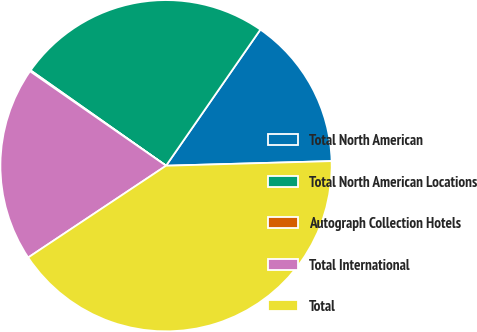Convert chart to OTSL. <chart><loc_0><loc_0><loc_500><loc_500><pie_chart><fcel>Total North American<fcel>Total North American Locations<fcel>Autograph Collection Hotels<fcel>Total International<fcel>Total<nl><fcel>14.91%<fcel>24.88%<fcel>0.1%<fcel>19.01%<fcel>41.09%<nl></chart> 